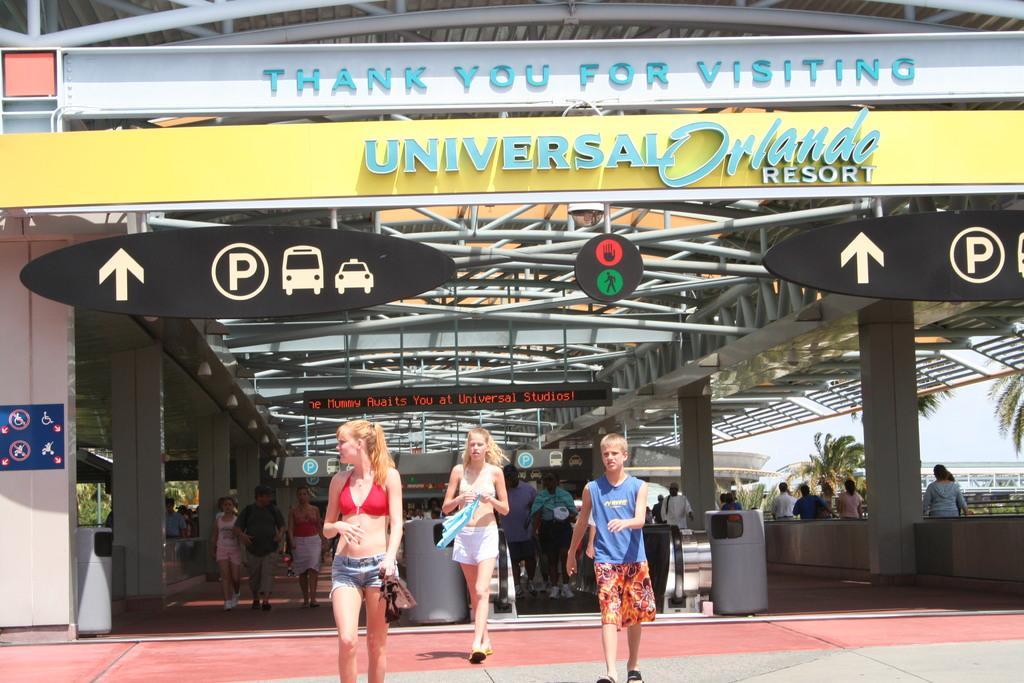Can you describe this image briefly? In this picture we can see some people are walking on the floor, direction boards, name boards, pillars, rods, some objects and in the background we can see trees and the sky. 